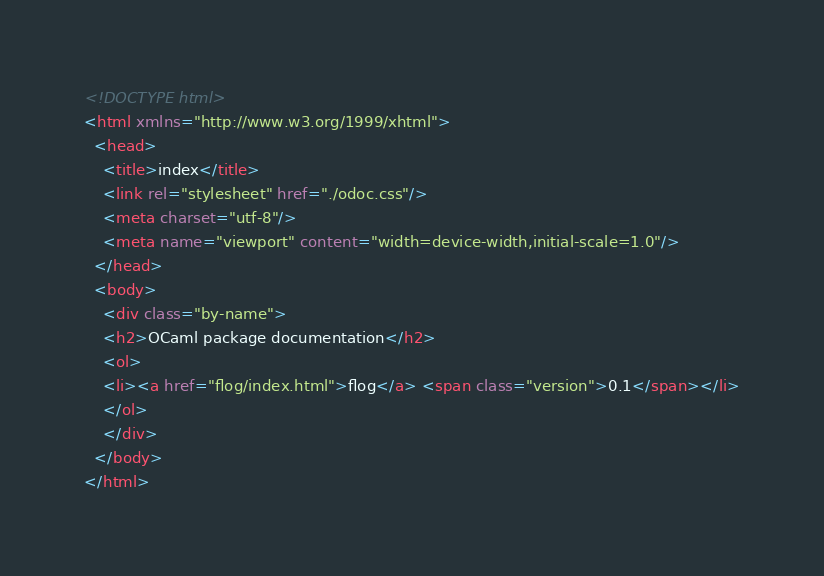<code> <loc_0><loc_0><loc_500><loc_500><_HTML_><!DOCTYPE html>
<html xmlns="http://www.w3.org/1999/xhtml">
  <head>
    <title>index</title>
    <link rel="stylesheet" href="./odoc.css"/>
    <meta charset="utf-8"/>
    <meta name="viewport" content="width=device-width,initial-scale=1.0"/>
  </head>
  <body>
    <div class="by-name">
    <h2>OCaml package documentation</h2>
    <ol>
    <li><a href="flog/index.html">flog</a> <span class="version">0.1</span></li>
    </ol>
    </div>
  </body>
</html></code> 